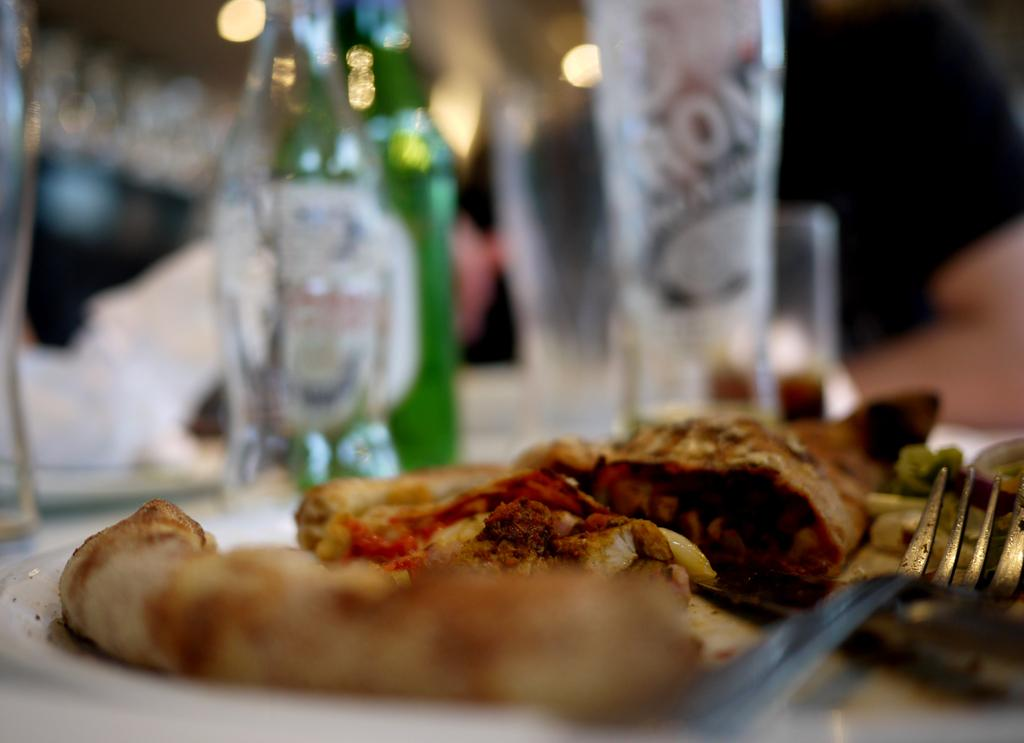What type of items can be seen on the table in the image? There are liquor bottles and food items on a table in the image. Can you describe the liquor bottles in more detail? Unfortunately, the image does not provide enough detail to describe the liquor bottles further. What kind of food items are present on the table? The image does not specify the type of food items on the table. Where is the boy playing with his wool toy in the image? There is no boy or wool toy present in the image. 